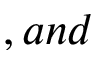<formula> <loc_0><loc_0><loc_500><loc_500>, a n d</formula> 